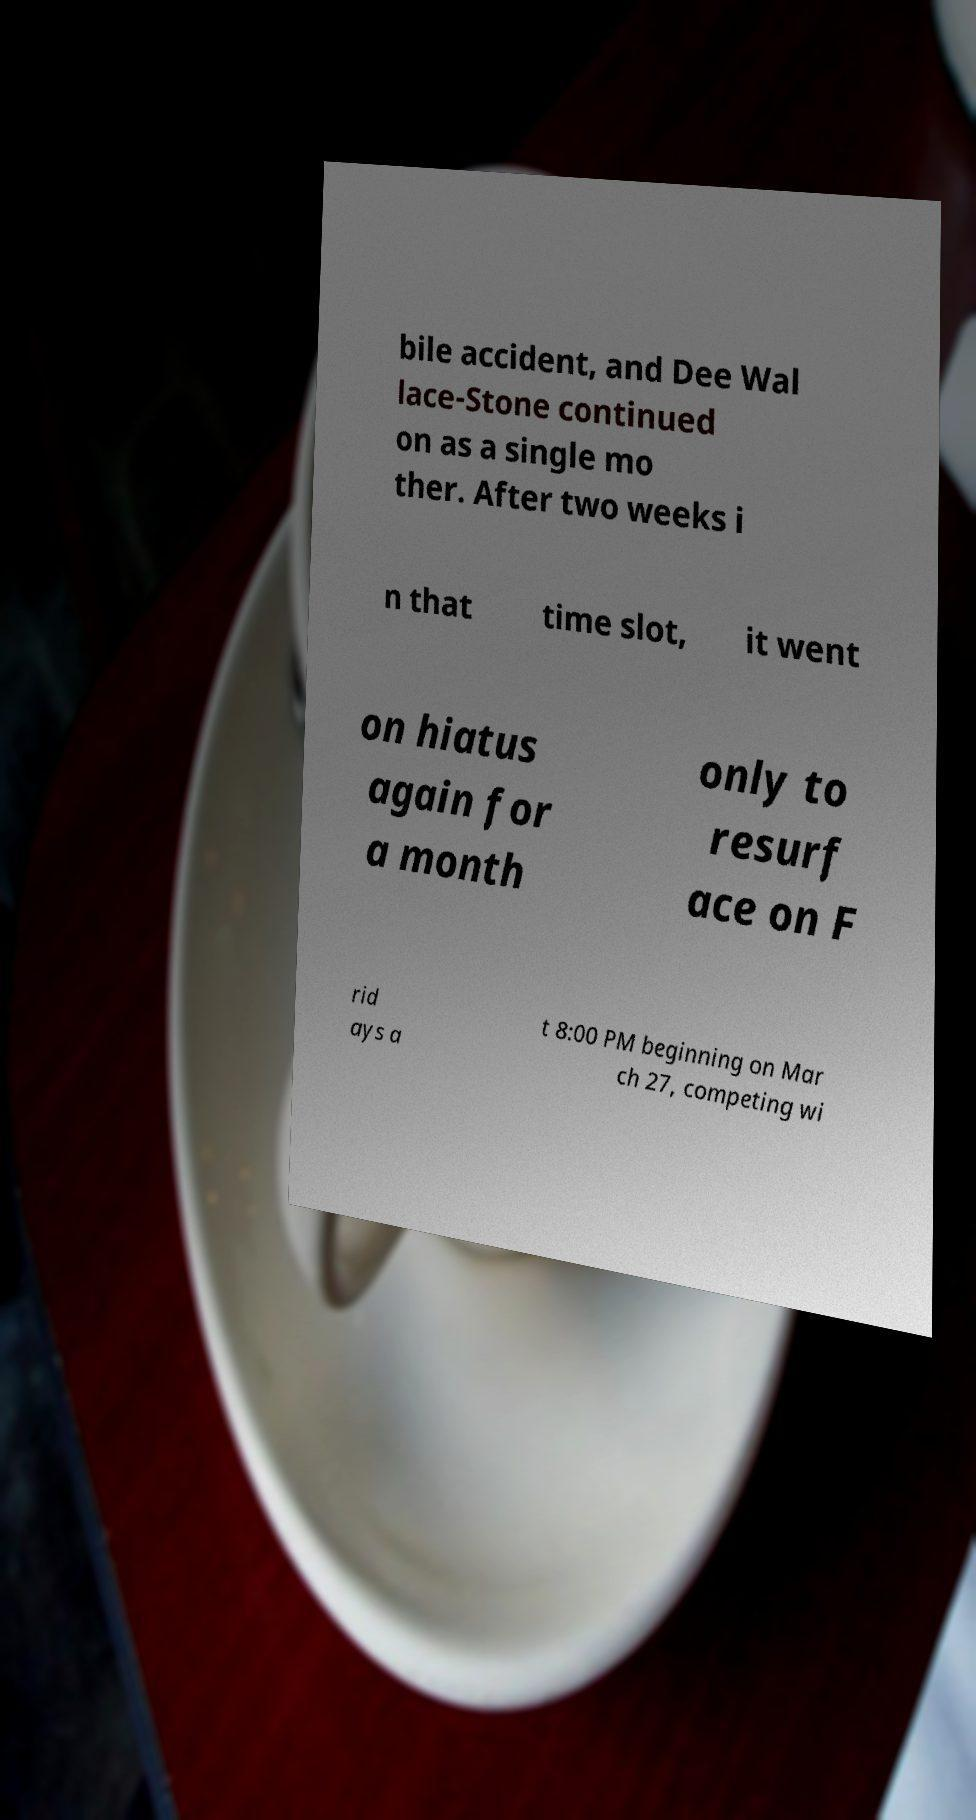Please identify and transcribe the text found in this image. bile accident, and Dee Wal lace-Stone continued on as a single mo ther. After two weeks i n that time slot, it went on hiatus again for a month only to resurf ace on F rid ays a t 8:00 PM beginning on Mar ch 27, competing wi 